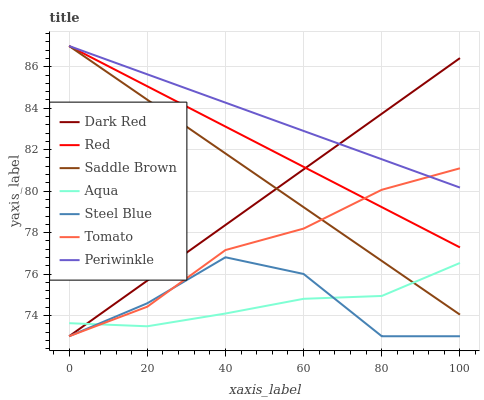Does Aqua have the minimum area under the curve?
Answer yes or no. Yes. Does Periwinkle have the maximum area under the curve?
Answer yes or no. Yes. Does Dark Red have the minimum area under the curve?
Answer yes or no. No. Does Dark Red have the maximum area under the curve?
Answer yes or no. No. Is Saddle Brown the smoothest?
Answer yes or no. Yes. Is Steel Blue the roughest?
Answer yes or no. Yes. Is Dark Red the smoothest?
Answer yes or no. No. Is Dark Red the roughest?
Answer yes or no. No. Does Tomato have the lowest value?
Answer yes or no. Yes. Does Aqua have the lowest value?
Answer yes or no. No. Does Red have the highest value?
Answer yes or no. Yes. Does Dark Red have the highest value?
Answer yes or no. No. Is Steel Blue less than Red?
Answer yes or no. Yes. Is Saddle Brown greater than Steel Blue?
Answer yes or no. Yes. Does Red intersect Tomato?
Answer yes or no. Yes. Is Red less than Tomato?
Answer yes or no. No. Is Red greater than Tomato?
Answer yes or no. No. Does Steel Blue intersect Red?
Answer yes or no. No. 